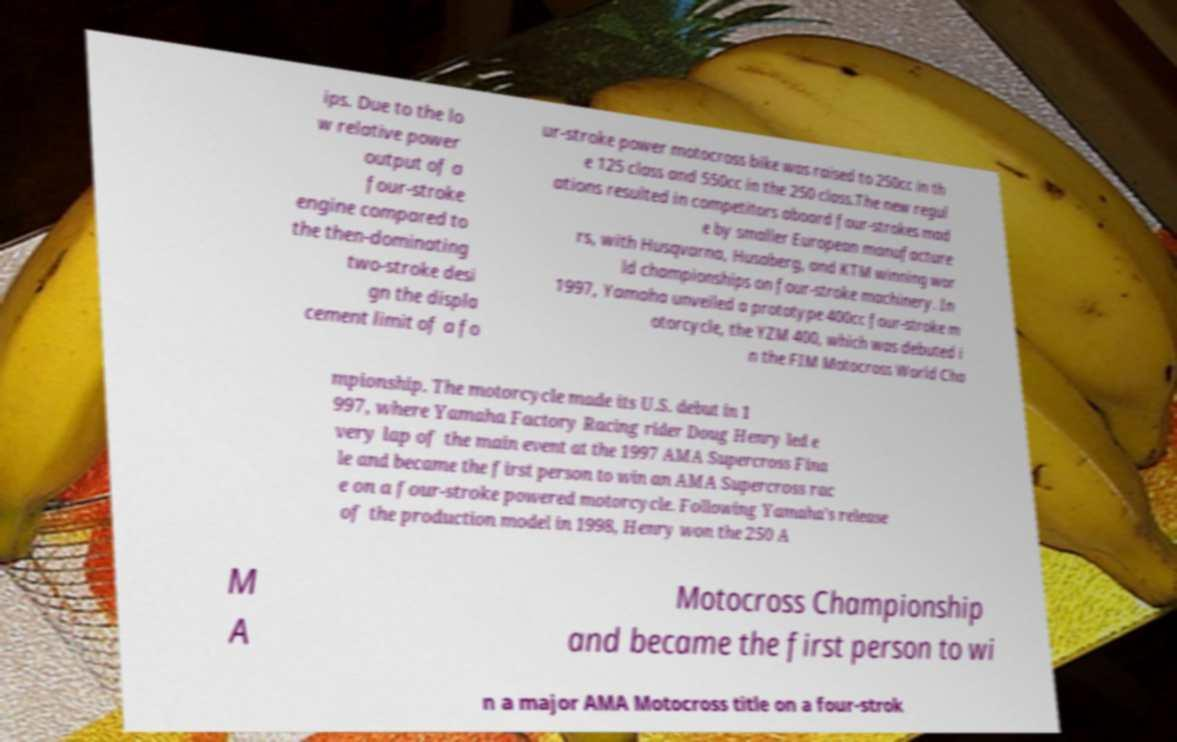Please read and relay the text visible in this image. What does it say? ips. Due to the lo w relative power output of a four-stroke engine compared to the then-dominating two-stroke desi gn the displa cement limit of a fo ur-stroke power motocross bike was raised to 250cc in th e 125 class and 550cc in the 250 class.The new regul ations resulted in competitors aboard four-strokes mad e by smaller European manufacture rs, with Husqvarna, Husaberg, and KTM winning wor ld championships on four-stroke machinery. In 1997, Yamaha unveiled a prototype 400cc four-stroke m otorcycle, the YZM 400, which was debuted i n the FIM Motocross World Cha mpionship. The motorcycle made its U.S. debut in 1 997, where Yamaha Factory Racing rider Doug Henry led e very lap of the main event at the 1997 AMA Supercross Fina le and became the first person to win an AMA Supercross rac e on a four-stroke powered motorcycle. Following Yamaha’s release of the production model in 1998, Henry won the 250 A M A Motocross Championship and became the first person to wi n a major AMA Motocross title on a four-strok 